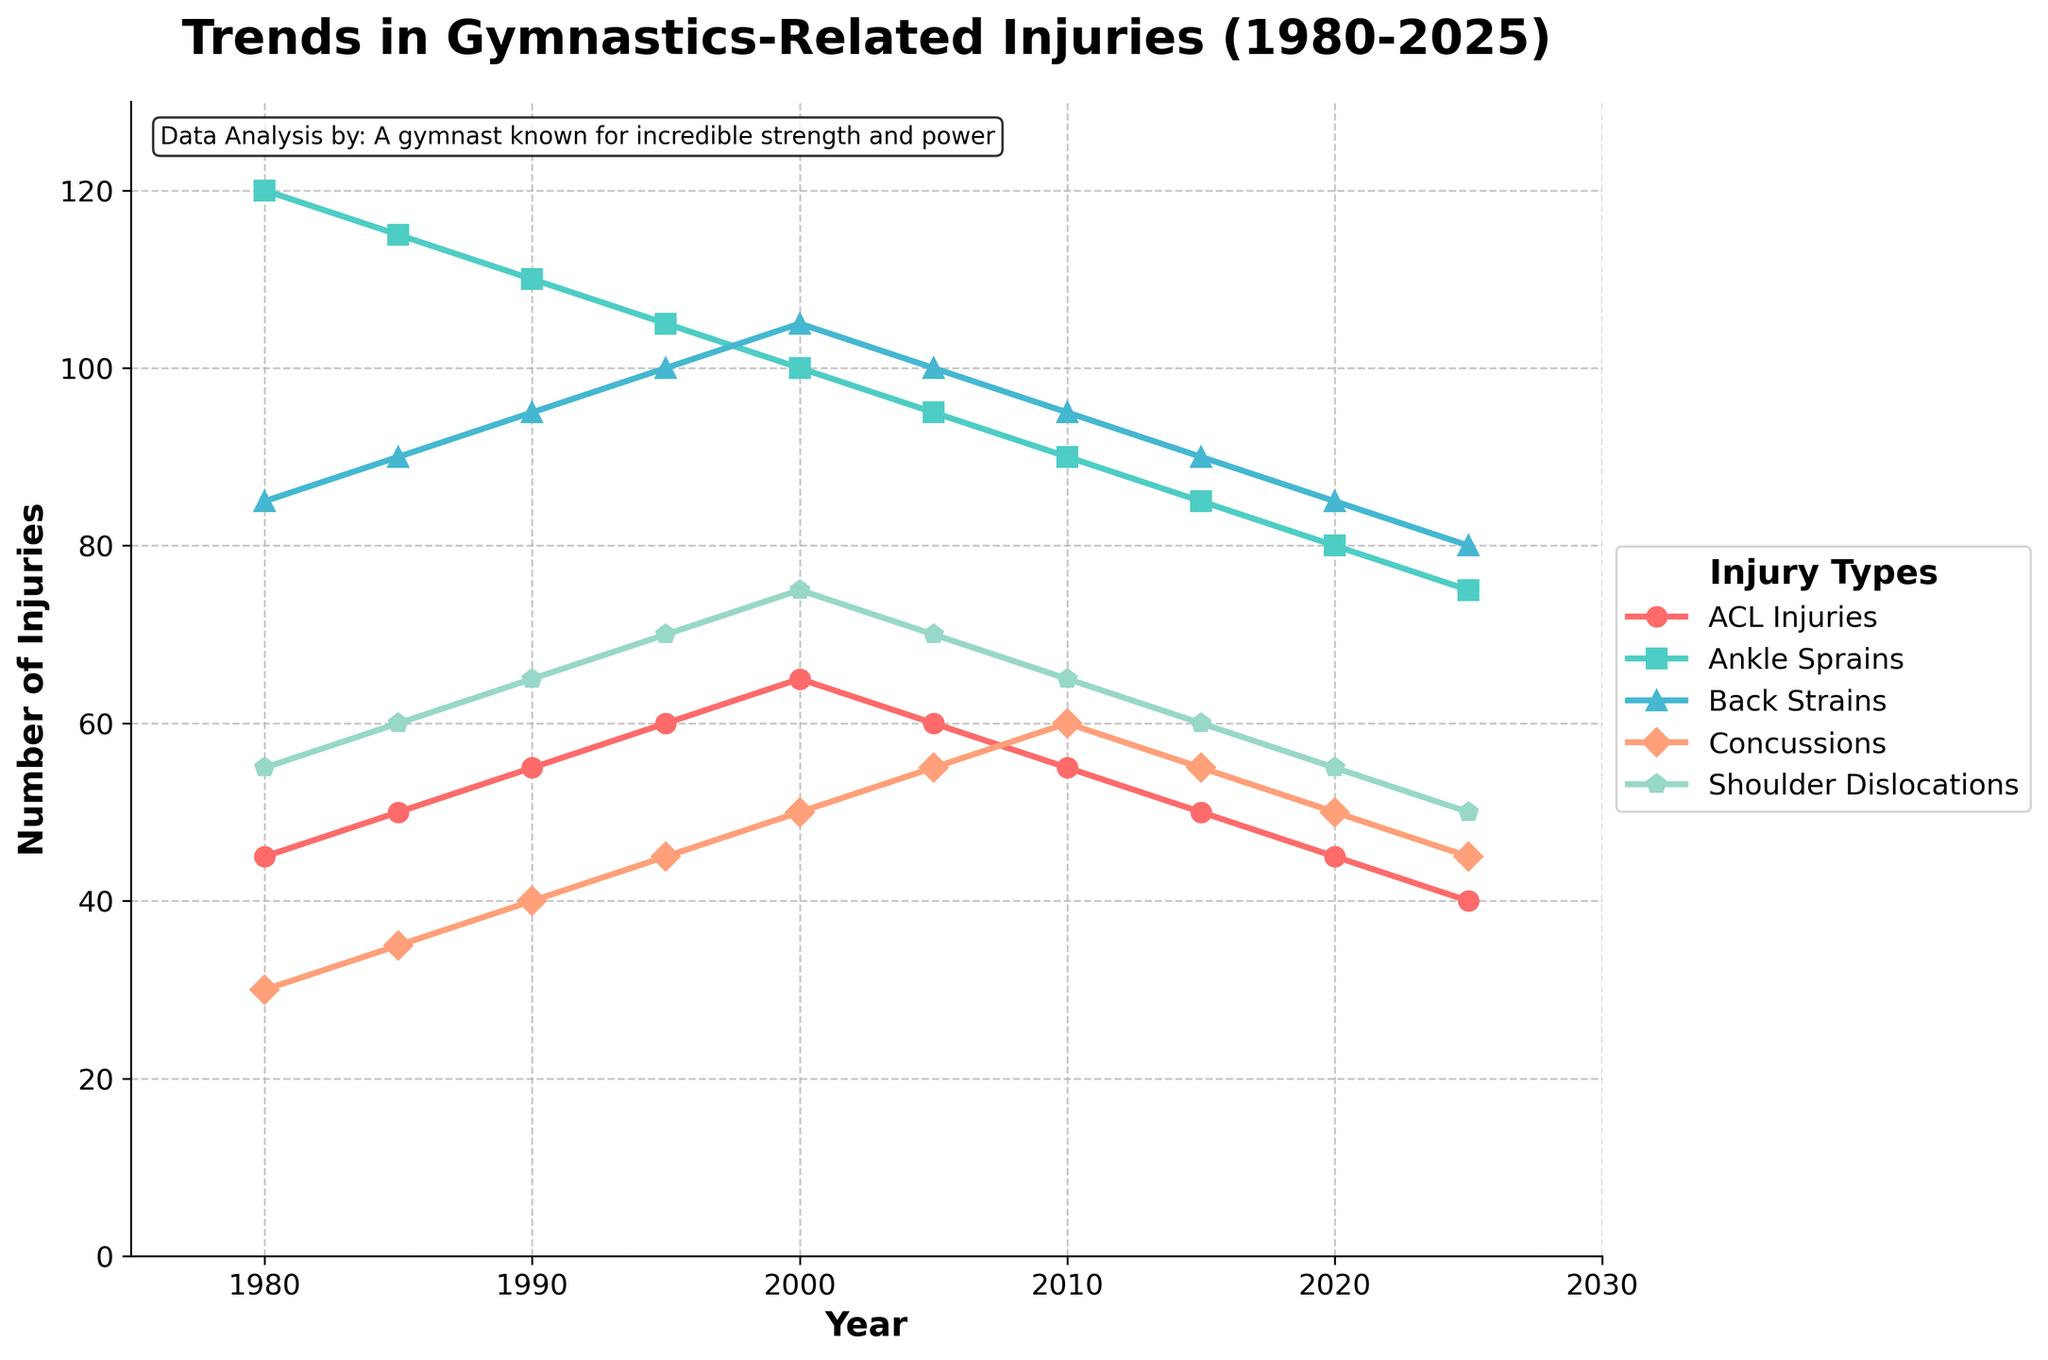What was the trend in ACL injuries from 1980 to 2025? Observe the line representing ACL injuries on the chart. It starts at 45 in 1980, increases gradually to a peak of 65 in 2000, and then declines to 40 by 2025.
Answer: Increasing until 2000, then decreasing By how much did ankle sprains decrease from 1980 to 2025? Find the values for ankle sprains in 1980 and 2025: 120 and 75 respectively. Subtract the latter from the former: 120 - 75 = 45.
Answer: 45 Which injury type saw the highest number in the year 2000? Check the highest points for each injury type in the year 2000. Back strains had the highest value with 105 injuries.
Answer: Back strains What is the difference in the number of concussions between 1995 and 2010? Find the values for concussions in 1995 and 2010: 45 and 60 respectively. Subtract 45 from 60: 60 - 45 = 15.
Answer: 15 What was the decade with the highest number of shoulder dislocations? Look at the values for shoulder dislocations across each decade and identify the peak: the highest value is 75 in 2000.
Answer: 2000s Which injury type decreased the most from its peak to 2025? Identify each injury type's peak and their value in 2025, then calculate the decrease. ACL injuries peaked at 65 and decreased to 40, a decrease of 25, which is the highest among all injury types.
Answer: ACL injuries Are there any injury types that followed a similar trend over the decades? Observe the lines representing different injury types and check for similar patterns. ACL Injuries and ankle sprains both initially increase and then decrease over the decades.
Answer: ACL injuries and ankle sprains On what visual attribute did you identify peaks and trends for each injury type? The peaks and trends were identified by observing the height of the lines on the y-axis over time.
Answer: Height of lines on y-axis 